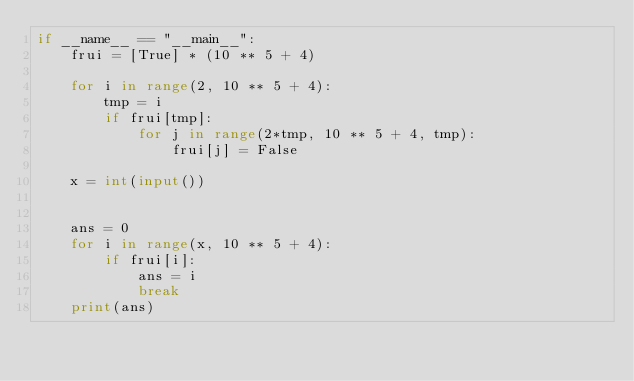<code> <loc_0><loc_0><loc_500><loc_500><_Python_>if __name__ == "__main__":
    frui = [True] * (10 ** 5 + 4)

    for i in range(2, 10 ** 5 + 4):
        tmp = i
        if frui[tmp]:
            for j in range(2*tmp, 10 ** 5 + 4, tmp):
                frui[j] = False
    
    x = int(input())


    ans = 0
    for i in range(x, 10 ** 5 + 4):
        if frui[i]:
            ans = i
            break
    print(ans)</code> 